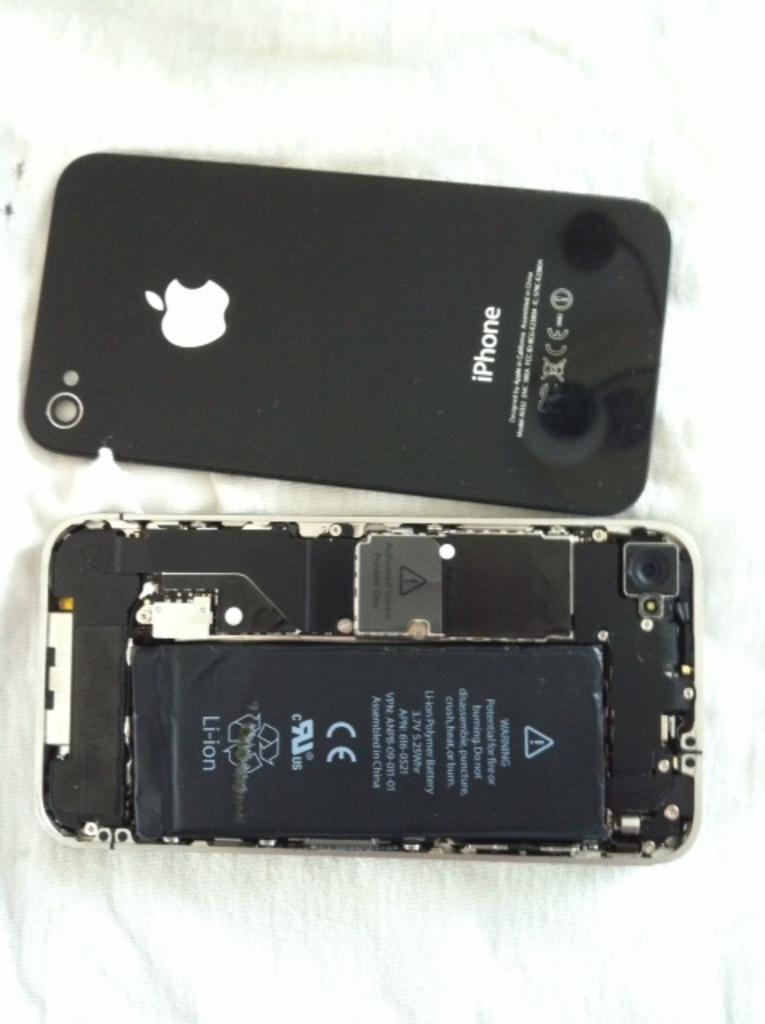<image>
Summarize the visual content of the image. the back side of an iPHONE and its battery showing 